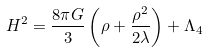<formula> <loc_0><loc_0><loc_500><loc_500>H ^ { 2 } = \frac { 8 \pi G } { 3 } \left ( \rho + \frac { \rho ^ { 2 } } { 2 \lambda } \right ) + \Lambda _ { 4 }</formula> 